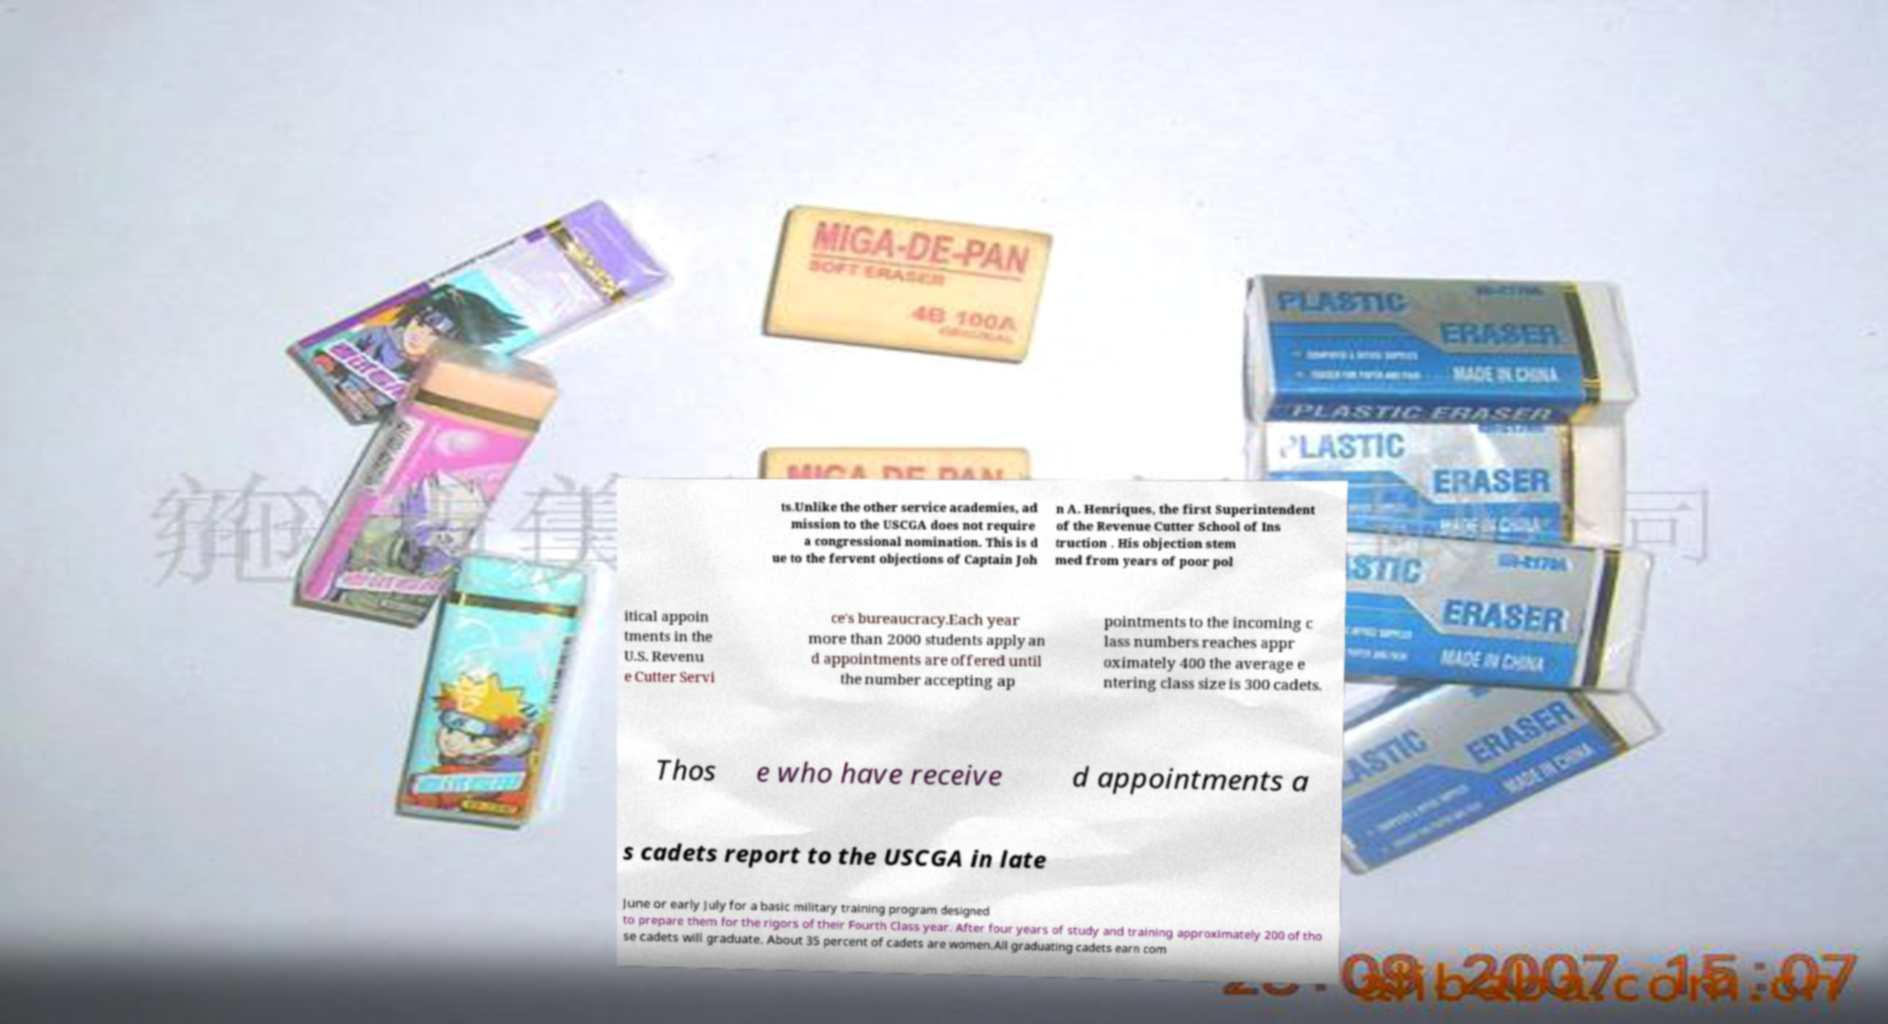There's text embedded in this image that I need extracted. Can you transcribe it verbatim? ts.Unlike the other service academies, ad mission to the USCGA does not require a congressional nomination. This is d ue to the fervent objections of Captain Joh n A. Henriques, the first Superintendent of the Revenue Cutter School of Ins truction . His objection stem med from years of poor pol itical appoin tments in the U.S. Revenu e Cutter Servi ce's bureaucracy.Each year more than 2000 students apply an d appointments are offered until the number accepting ap pointments to the incoming c lass numbers reaches appr oximately 400 the average e ntering class size is 300 cadets. Thos e who have receive d appointments a s cadets report to the USCGA in late June or early July for a basic military training program designed to prepare them for the rigors of their Fourth Class year. After four years of study and training approximately 200 of tho se cadets will graduate. About 35 percent of cadets are women.All graduating cadets earn com 